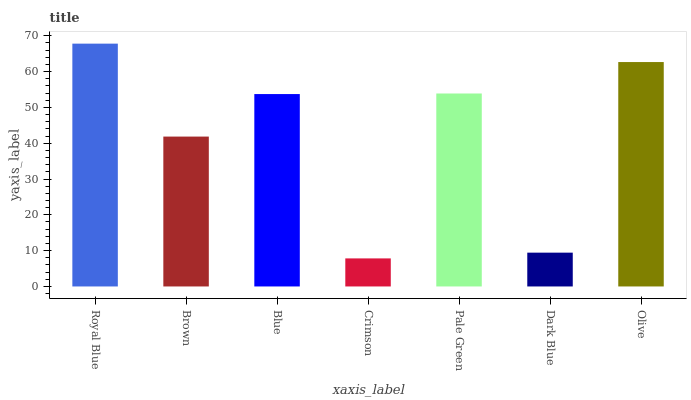Is Crimson the minimum?
Answer yes or no. Yes. Is Royal Blue the maximum?
Answer yes or no. Yes. Is Brown the minimum?
Answer yes or no. No. Is Brown the maximum?
Answer yes or no. No. Is Royal Blue greater than Brown?
Answer yes or no. Yes. Is Brown less than Royal Blue?
Answer yes or no. Yes. Is Brown greater than Royal Blue?
Answer yes or no. No. Is Royal Blue less than Brown?
Answer yes or no. No. Is Blue the high median?
Answer yes or no. Yes. Is Blue the low median?
Answer yes or no. Yes. Is Dark Blue the high median?
Answer yes or no. No. Is Dark Blue the low median?
Answer yes or no. No. 